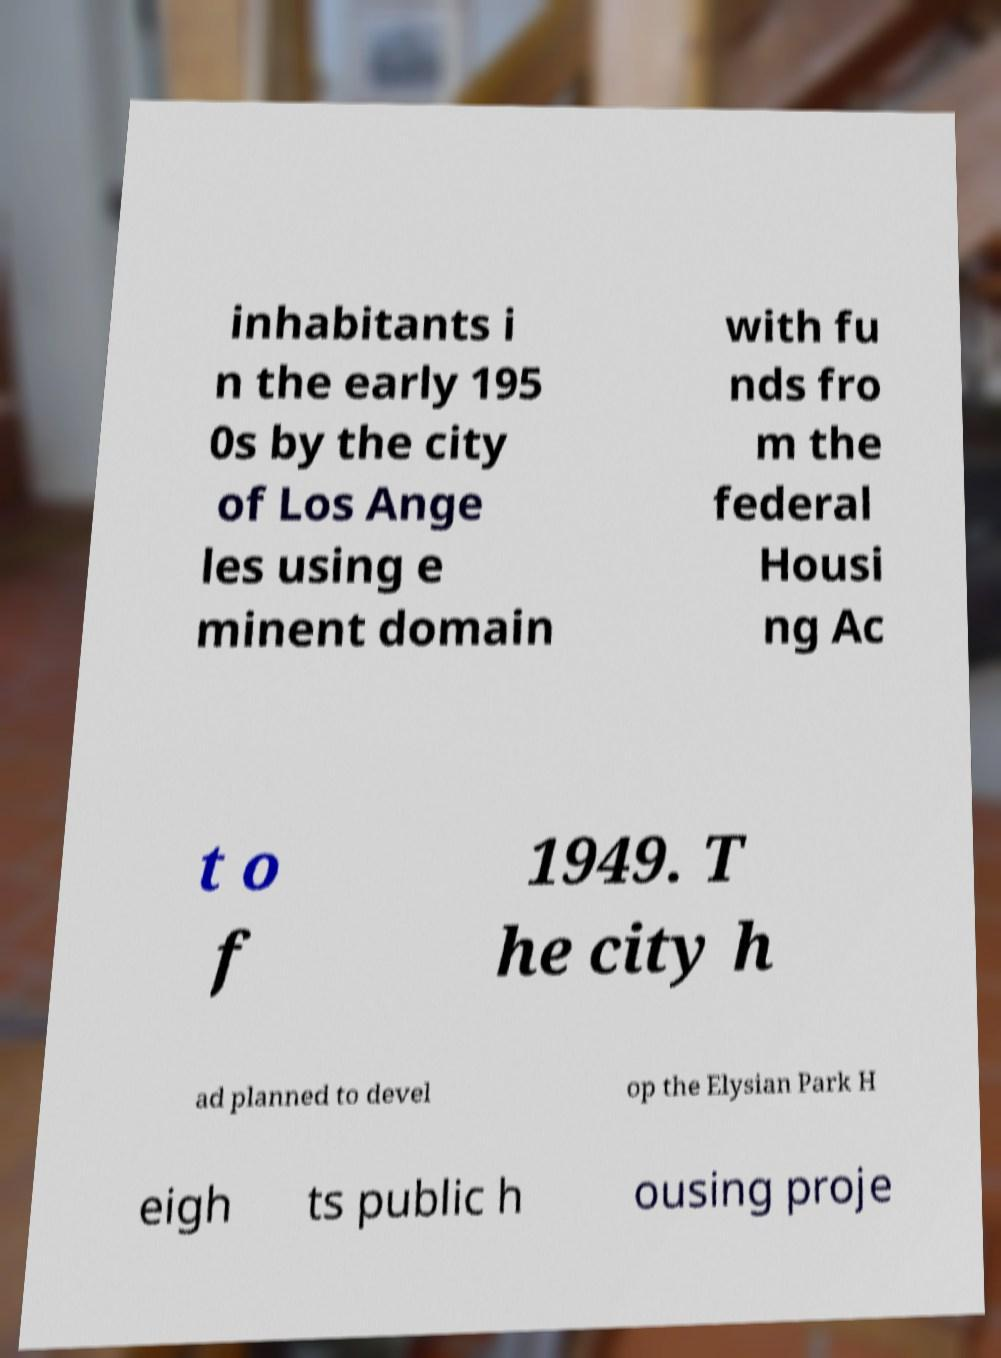Can you read and provide the text displayed in the image?This photo seems to have some interesting text. Can you extract and type it out for me? inhabitants i n the early 195 0s by the city of Los Ange les using e minent domain with fu nds fro m the federal Housi ng Ac t o f 1949. T he city h ad planned to devel op the Elysian Park H eigh ts public h ousing proje 